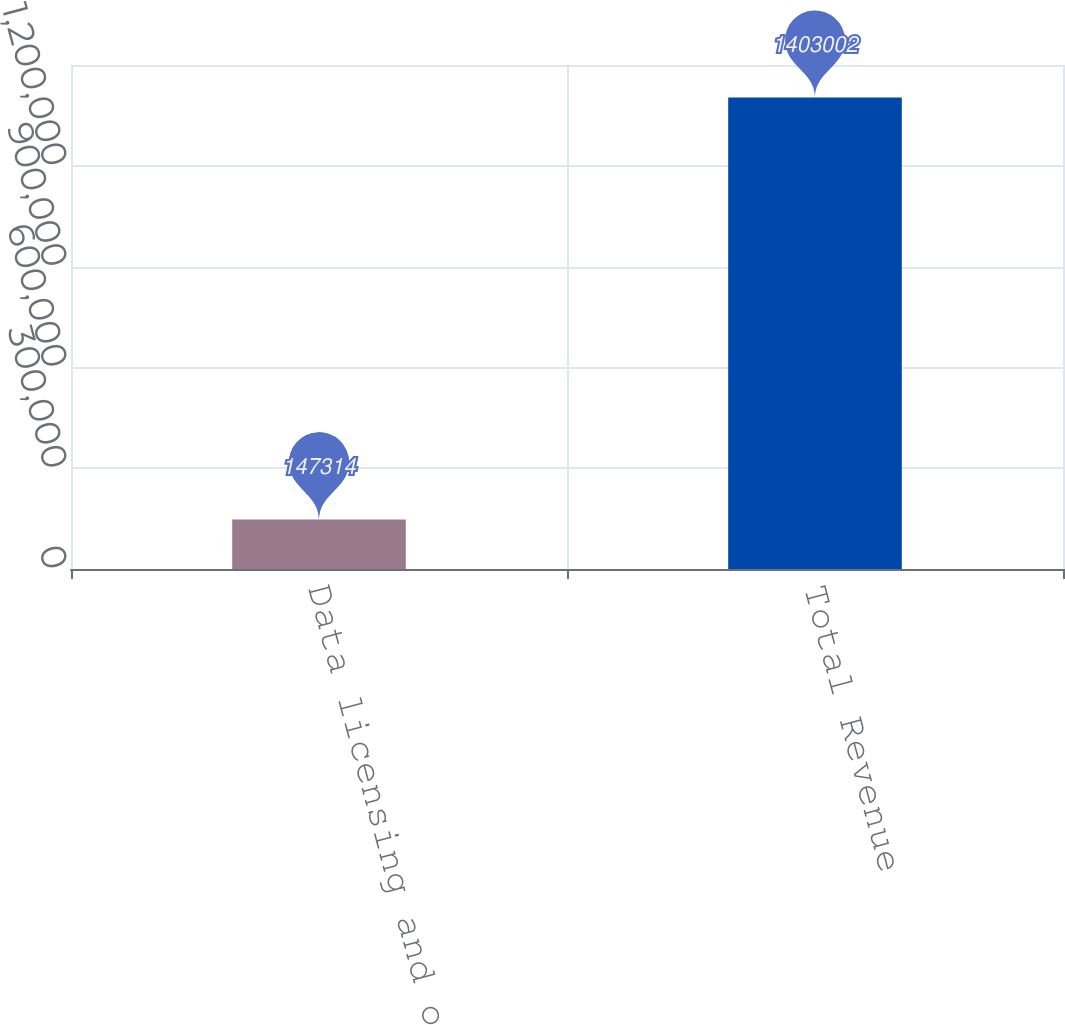<chart> <loc_0><loc_0><loc_500><loc_500><bar_chart><fcel>Data licensing and other<fcel>Total Revenue<nl><fcel>147314<fcel>1.403e+06<nl></chart> 